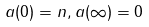Convert formula to latex. <formula><loc_0><loc_0><loc_500><loc_500>a ( 0 ) = n , a ( \infty ) = 0</formula> 